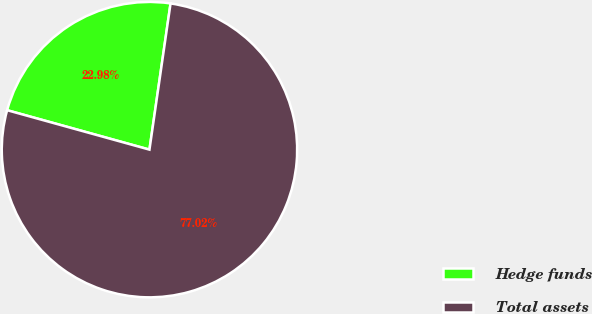Convert chart to OTSL. <chart><loc_0><loc_0><loc_500><loc_500><pie_chart><fcel>Hedge funds<fcel>Total assets<nl><fcel>22.98%<fcel>77.02%<nl></chart> 